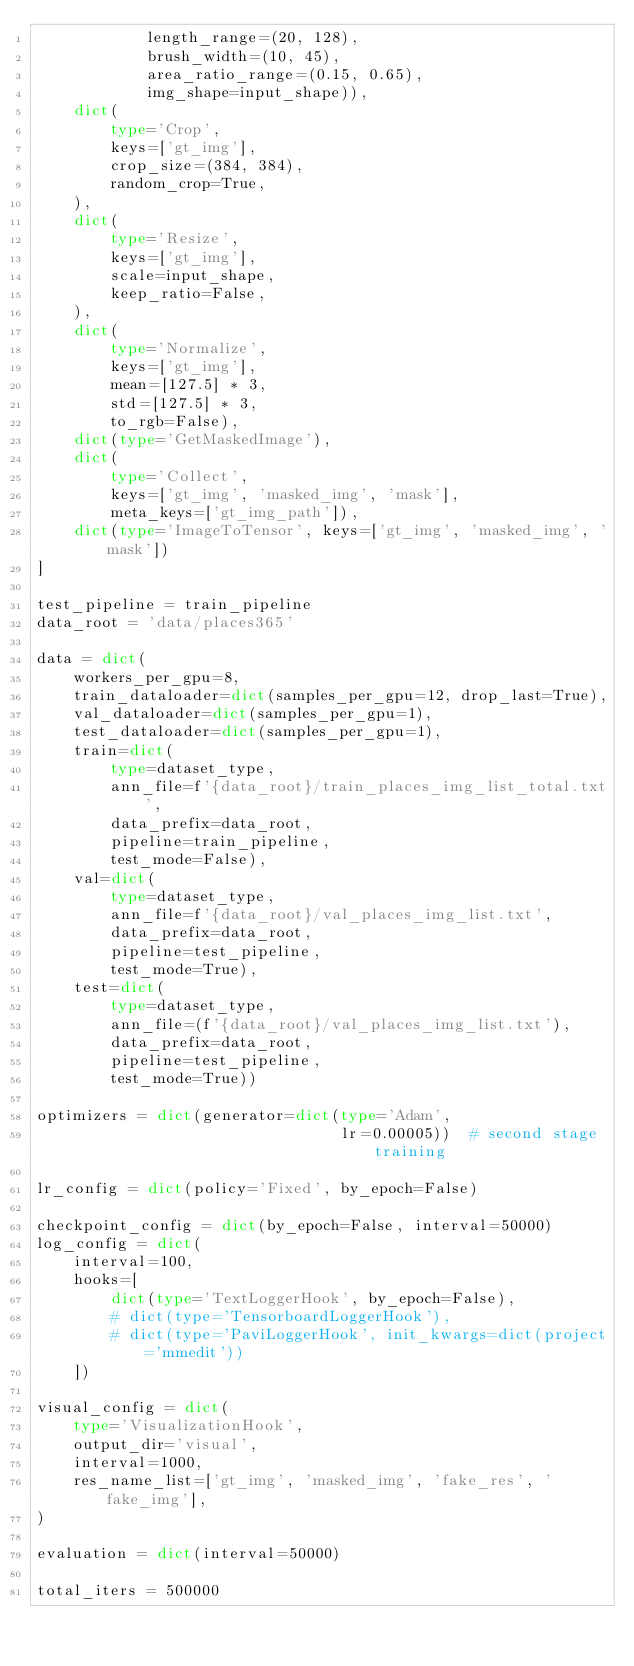<code> <loc_0><loc_0><loc_500><loc_500><_Python_>            length_range=(20, 128),
            brush_width=(10, 45),
            area_ratio_range=(0.15, 0.65),
            img_shape=input_shape)),
    dict(
        type='Crop',
        keys=['gt_img'],
        crop_size=(384, 384),
        random_crop=True,
    ),
    dict(
        type='Resize',
        keys=['gt_img'],
        scale=input_shape,
        keep_ratio=False,
    ),
    dict(
        type='Normalize',
        keys=['gt_img'],
        mean=[127.5] * 3,
        std=[127.5] * 3,
        to_rgb=False),
    dict(type='GetMaskedImage'),
    dict(
        type='Collect',
        keys=['gt_img', 'masked_img', 'mask'],
        meta_keys=['gt_img_path']),
    dict(type='ImageToTensor', keys=['gt_img', 'masked_img', 'mask'])
]

test_pipeline = train_pipeline
data_root = 'data/places365'

data = dict(
    workers_per_gpu=8,
    train_dataloader=dict(samples_per_gpu=12, drop_last=True),
    val_dataloader=dict(samples_per_gpu=1),
    test_dataloader=dict(samples_per_gpu=1),
    train=dict(
        type=dataset_type,
        ann_file=f'{data_root}/train_places_img_list_total.txt',
        data_prefix=data_root,
        pipeline=train_pipeline,
        test_mode=False),
    val=dict(
        type=dataset_type,
        ann_file=f'{data_root}/val_places_img_list.txt',
        data_prefix=data_root,
        pipeline=test_pipeline,
        test_mode=True),
    test=dict(
        type=dataset_type,
        ann_file=(f'{data_root}/val_places_img_list.txt'),
        data_prefix=data_root,
        pipeline=test_pipeline,
        test_mode=True))

optimizers = dict(generator=dict(type='Adam',
                                 lr=0.00005))  # second stage training

lr_config = dict(policy='Fixed', by_epoch=False)

checkpoint_config = dict(by_epoch=False, interval=50000)
log_config = dict(
    interval=100,
    hooks=[
        dict(type='TextLoggerHook', by_epoch=False),
        # dict(type='TensorboardLoggerHook'),
        # dict(type='PaviLoggerHook', init_kwargs=dict(project='mmedit'))
    ])

visual_config = dict(
    type='VisualizationHook',
    output_dir='visual',
    interval=1000,
    res_name_list=['gt_img', 'masked_img', 'fake_res', 'fake_img'],
)

evaluation = dict(interval=50000)

total_iters = 500000</code> 